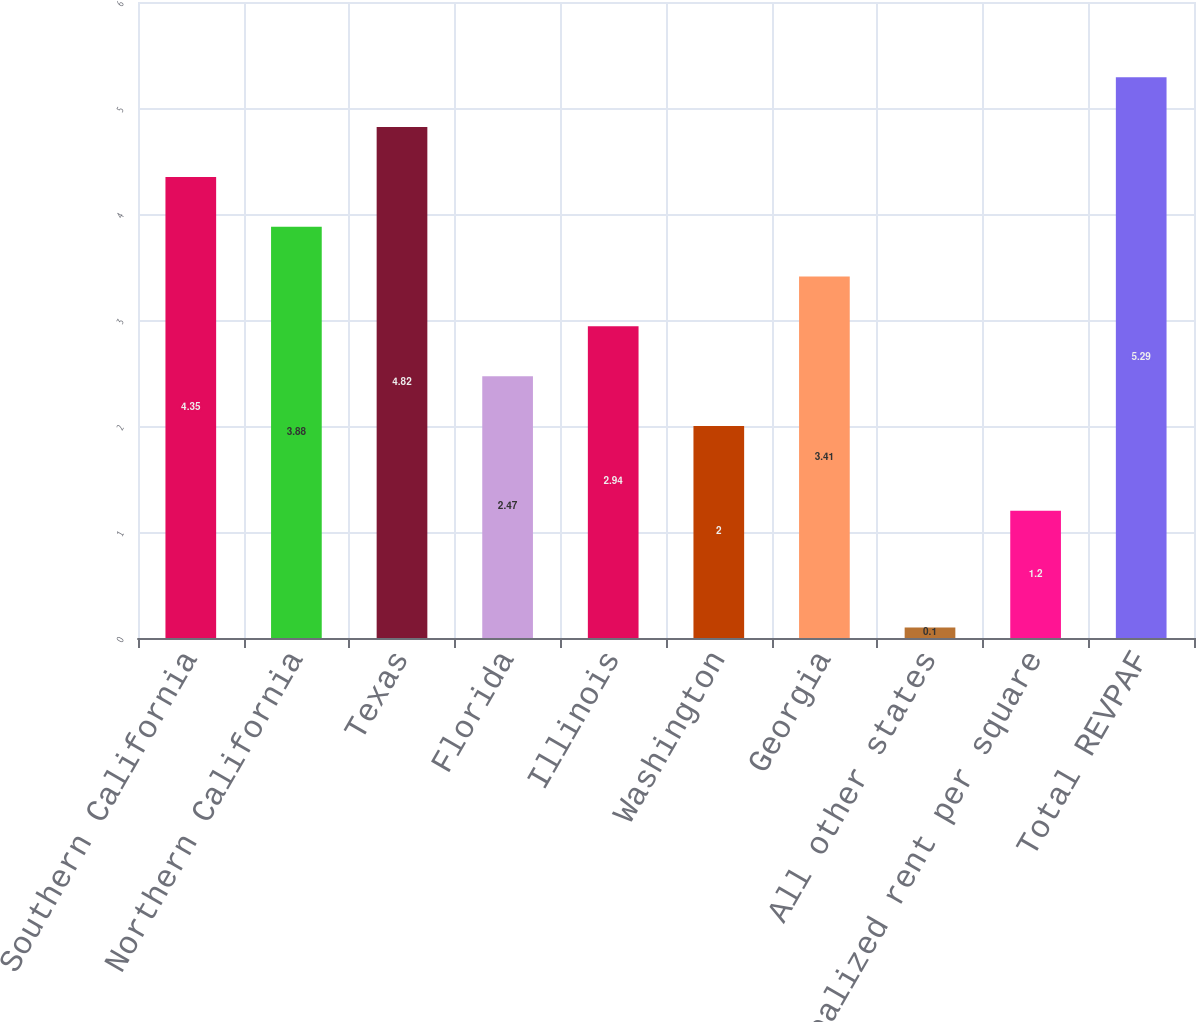Convert chart to OTSL. <chart><loc_0><loc_0><loc_500><loc_500><bar_chart><fcel>Southern California<fcel>Northern California<fcel>Texas<fcel>Florida<fcel>Illinois<fcel>Washington<fcel>Georgia<fcel>All other states<fcel>Total realized rent per square<fcel>Total REVPAF<nl><fcel>4.35<fcel>3.88<fcel>4.82<fcel>2.47<fcel>2.94<fcel>2<fcel>3.41<fcel>0.1<fcel>1.2<fcel>5.29<nl></chart> 